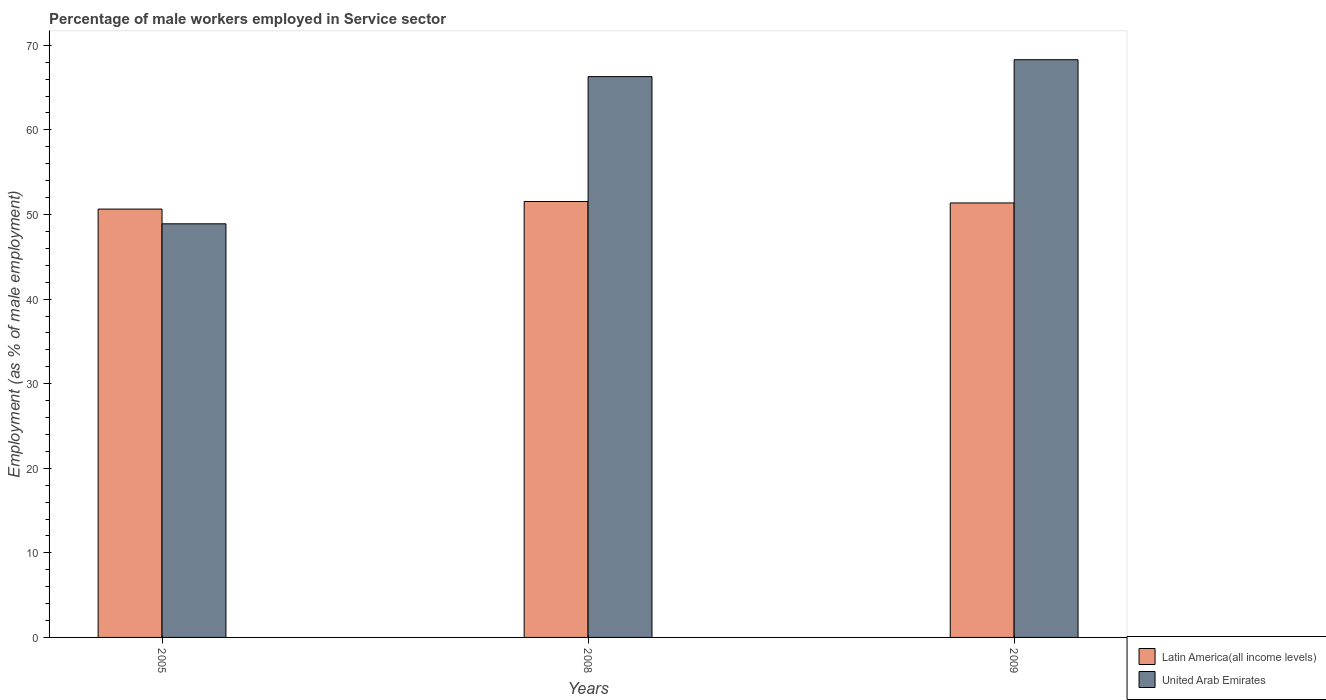Are the number of bars on each tick of the X-axis equal?
Make the answer very short. Yes. How many bars are there on the 1st tick from the left?
Provide a short and direct response. 2. How many bars are there on the 1st tick from the right?
Offer a terse response. 2. What is the percentage of male workers employed in Service sector in Latin America(all income levels) in 2009?
Give a very brief answer. 51.37. Across all years, what is the maximum percentage of male workers employed in Service sector in United Arab Emirates?
Offer a terse response. 68.3. Across all years, what is the minimum percentage of male workers employed in Service sector in United Arab Emirates?
Give a very brief answer. 48.9. In which year was the percentage of male workers employed in Service sector in Latin America(all income levels) maximum?
Give a very brief answer. 2008. What is the total percentage of male workers employed in Service sector in United Arab Emirates in the graph?
Keep it short and to the point. 183.5. What is the difference between the percentage of male workers employed in Service sector in Latin America(all income levels) in 2005 and that in 2009?
Provide a short and direct response. -0.72. What is the difference between the percentage of male workers employed in Service sector in United Arab Emirates in 2008 and the percentage of male workers employed in Service sector in Latin America(all income levels) in 2009?
Offer a very short reply. 14.93. What is the average percentage of male workers employed in Service sector in United Arab Emirates per year?
Make the answer very short. 61.17. In the year 2009, what is the difference between the percentage of male workers employed in Service sector in United Arab Emirates and percentage of male workers employed in Service sector in Latin America(all income levels)?
Offer a terse response. 16.93. What is the ratio of the percentage of male workers employed in Service sector in Latin America(all income levels) in 2005 to that in 2008?
Ensure brevity in your answer.  0.98. Is the percentage of male workers employed in Service sector in Latin America(all income levels) in 2008 less than that in 2009?
Offer a very short reply. No. What is the difference between the highest and the second highest percentage of male workers employed in Service sector in Latin America(all income levels)?
Ensure brevity in your answer.  0.17. What is the difference between the highest and the lowest percentage of male workers employed in Service sector in United Arab Emirates?
Provide a succinct answer. 19.4. In how many years, is the percentage of male workers employed in Service sector in Latin America(all income levels) greater than the average percentage of male workers employed in Service sector in Latin America(all income levels) taken over all years?
Ensure brevity in your answer.  2. What does the 1st bar from the left in 2005 represents?
Provide a short and direct response. Latin America(all income levels). What does the 1st bar from the right in 2008 represents?
Ensure brevity in your answer.  United Arab Emirates. How many years are there in the graph?
Offer a terse response. 3. Are the values on the major ticks of Y-axis written in scientific E-notation?
Offer a terse response. No. Does the graph contain any zero values?
Provide a succinct answer. No. Does the graph contain grids?
Offer a very short reply. No. How many legend labels are there?
Offer a very short reply. 2. How are the legend labels stacked?
Your answer should be very brief. Vertical. What is the title of the graph?
Provide a succinct answer. Percentage of male workers employed in Service sector. Does "Indonesia" appear as one of the legend labels in the graph?
Offer a terse response. No. What is the label or title of the Y-axis?
Your answer should be very brief. Employment (as % of male employment). What is the Employment (as % of male employment) of Latin America(all income levels) in 2005?
Provide a succinct answer. 50.64. What is the Employment (as % of male employment) of United Arab Emirates in 2005?
Keep it short and to the point. 48.9. What is the Employment (as % of male employment) of Latin America(all income levels) in 2008?
Offer a terse response. 51.54. What is the Employment (as % of male employment) in United Arab Emirates in 2008?
Your response must be concise. 66.3. What is the Employment (as % of male employment) in Latin America(all income levels) in 2009?
Offer a terse response. 51.37. What is the Employment (as % of male employment) in United Arab Emirates in 2009?
Provide a short and direct response. 68.3. Across all years, what is the maximum Employment (as % of male employment) in Latin America(all income levels)?
Your response must be concise. 51.54. Across all years, what is the maximum Employment (as % of male employment) in United Arab Emirates?
Your response must be concise. 68.3. Across all years, what is the minimum Employment (as % of male employment) in Latin America(all income levels)?
Your answer should be very brief. 50.64. Across all years, what is the minimum Employment (as % of male employment) in United Arab Emirates?
Your answer should be compact. 48.9. What is the total Employment (as % of male employment) of Latin America(all income levels) in the graph?
Provide a succinct answer. 153.54. What is the total Employment (as % of male employment) of United Arab Emirates in the graph?
Make the answer very short. 183.5. What is the difference between the Employment (as % of male employment) of Latin America(all income levels) in 2005 and that in 2008?
Your response must be concise. -0.89. What is the difference between the Employment (as % of male employment) of United Arab Emirates in 2005 and that in 2008?
Make the answer very short. -17.4. What is the difference between the Employment (as % of male employment) of Latin America(all income levels) in 2005 and that in 2009?
Provide a succinct answer. -0.72. What is the difference between the Employment (as % of male employment) in United Arab Emirates in 2005 and that in 2009?
Make the answer very short. -19.4. What is the difference between the Employment (as % of male employment) of Latin America(all income levels) in 2008 and that in 2009?
Give a very brief answer. 0.17. What is the difference between the Employment (as % of male employment) of Latin America(all income levels) in 2005 and the Employment (as % of male employment) of United Arab Emirates in 2008?
Make the answer very short. -15.66. What is the difference between the Employment (as % of male employment) in Latin America(all income levels) in 2005 and the Employment (as % of male employment) in United Arab Emirates in 2009?
Provide a succinct answer. -17.66. What is the difference between the Employment (as % of male employment) of Latin America(all income levels) in 2008 and the Employment (as % of male employment) of United Arab Emirates in 2009?
Ensure brevity in your answer.  -16.76. What is the average Employment (as % of male employment) of Latin America(all income levels) per year?
Offer a terse response. 51.18. What is the average Employment (as % of male employment) of United Arab Emirates per year?
Give a very brief answer. 61.17. In the year 2005, what is the difference between the Employment (as % of male employment) of Latin America(all income levels) and Employment (as % of male employment) of United Arab Emirates?
Offer a terse response. 1.74. In the year 2008, what is the difference between the Employment (as % of male employment) in Latin America(all income levels) and Employment (as % of male employment) in United Arab Emirates?
Your answer should be very brief. -14.76. In the year 2009, what is the difference between the Employment (as % of male employment) of Latin America(all income levels) and Employment (as % of male employment) of United Arab Emirates?
Provide a succinct answer. -16.93. What is the ratio of the Employment (as % of male employment) of Latin America(all income levels) in 2005 to that in 2008?
Provide a succinct answer. 0.98. What is the ratio of the Employment (as % of male employment) in United Arab Emirates in 2005 to that in 2008?
Make the answer very short. 0.74. What is the ratio of the Employment (as % of male employment) in Latin America(all income levels) in 2005 to that in 2009?
Your answer should be compact. 0.99. What is the ratio of the Employment (as % of male employment) of United Arab Emirates in 2005 to that in 2009?
Offer a very short reply. 0.72. What is the ratio of the Employment (as % of male employment) in Latin America(all income levels) in 2008 to that in 2009?
Your answer should be compact. 1. What is the ratio of the Employment (as % of male employment) of United Arab Emirates in 2008 to that in 2009?
Your answer should be very brief. 0.97. What is the difference between the highest and the second highest Employment (as % of male employment) in Latin America(all income levels)?
Your answer should be very brief. 0.17. What is the difference between the highest and the lowest Employment (as % of male employment) in Latin America(all income levels)?
Offer a terse response. 0.89. What is the difference between the highest and the lowest Employment (as % of male employment) of United Arab Emirates?
Your answer should be compact. 19.4. 